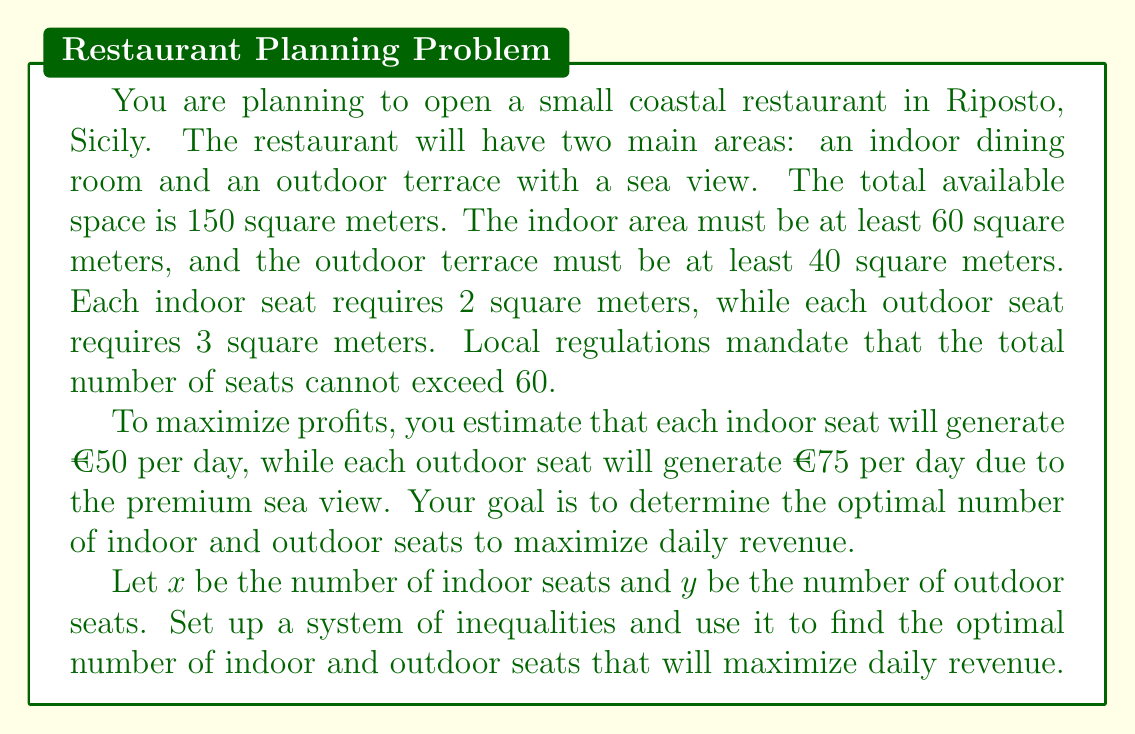Give your solution to this math problem. Let's approach this problem step by step:

1. First, let's define our variables:
   $x$ = number of indoor seats
   $y$ = number of outdoor seats

2. Now, let's set up our system of inequalities based on the given constraints:

   a) Total space constraint: $2x + 3y \leq 150$ (indoor space + outdoor space ≤ total space)
   b) Indoor area minimum: $2x \geq 60$ (indoor space ≥ 60)
   c) Outdoor area minimum: $3y \geq 40$ (outdoor space ≥ 40)
   d) Total seats constraint: $x + y \leq 60$ (total seats ≤ 60)
   e) Non-negativity: $x \geq 0, y \geq 0$

3. Our objective function (daily revenue) is:
   $R = 50x + 75y$

4. To solve this, we can use the corner point method. The feasible region is bounded by the inequalities above. We need to find the corner points of this region.

5. From the minimum area constraints:
   $x \geq 30$ (from $2x \geq 60$)
   $y \geq 13.33$ (from $3y \geq 40$)

6. The corner points are:
   (30, 13.33), (30, 30), (45, 15), (35, 25)

7. Let's calculate the revenue at each point:
   (30, 13.33): $R = 50(30) + 75(13.33) = 2500$
   (30, 30): $R = 50(30) + 75(30) = 3750$
   (45, 15): $R = 50(45) + 75(15) = 3375$
   (35, 25): $R = 50(35) + 75(25) = 3625$

8. The maximum revenue occurs at the point (30, 30).

Therefore, the optimal solution is to have 30 indoor seats and 30 outdoor seats, which will generate a daily revenue of €3750.
Answer: The optimal layout is 30 indoor seats and 30 outdoor seats, generating a maximum daily revenue of €3750. 